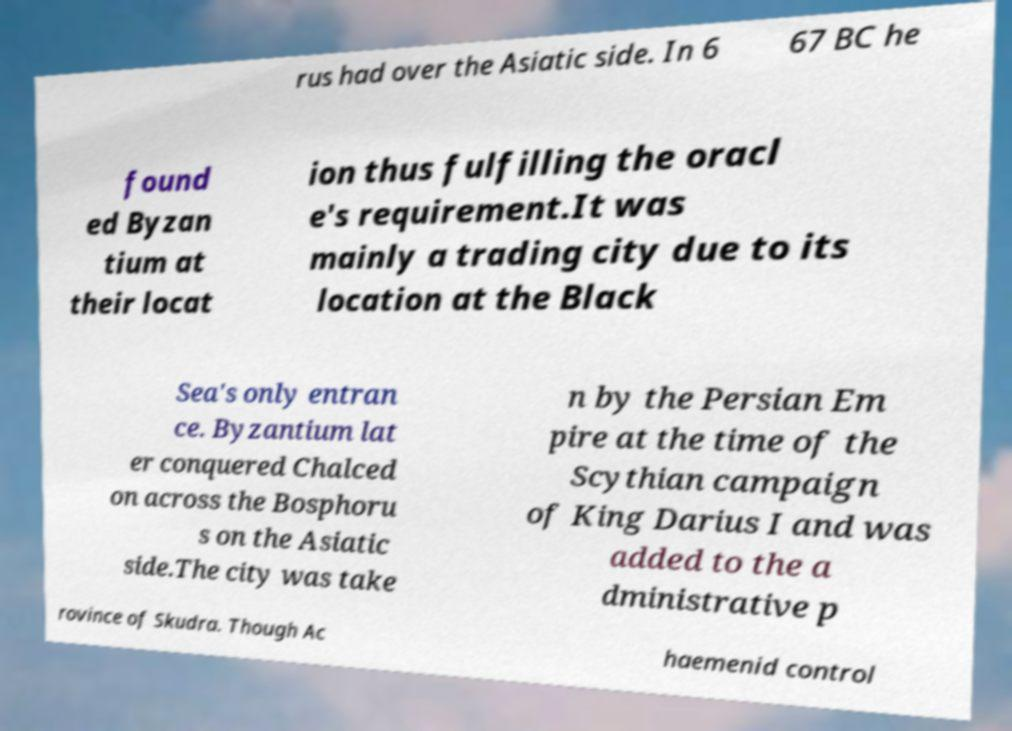Can you read and provide the text displayed in the image?This photo seems to have some interesting text. Can you extract and type it out for me? rus had over the Asiatic side. In 6 67 BC he found ed Byzan tium at their locat ion thus fulfilling the oracl e's requirement.It was mainly a trading city due to its location at the Black Sea's only entran ce. Byzantium lat er conquered Chalced on across the Bosphoru s on the Asiatic side.The city was take n by the Persian Em pire at the time of the Scythian campaign of King Darius I and was added to the a dministrative p rovince of Skudra. Though Ac haemenid control 